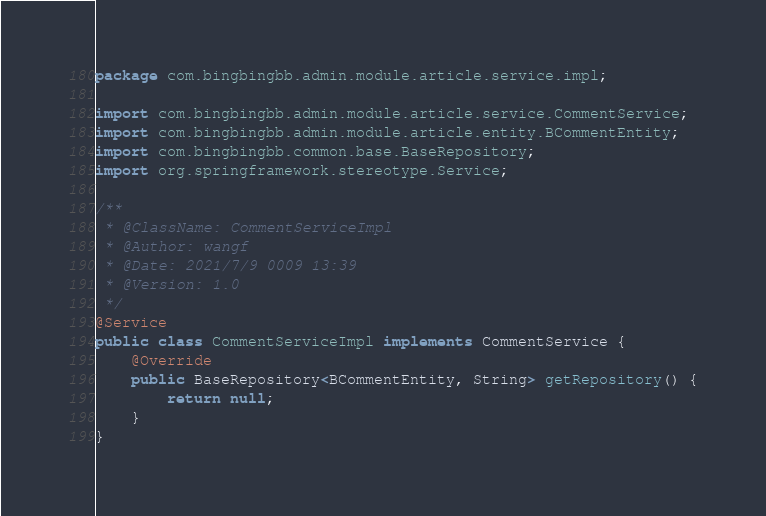Convert code to text. <code><loc_0><loc_0><loc_500><loc_500><_Java_>package com.bingbingbb.admin.module.article.service.impl;

import com.bingbingbb.admin.module.article.service.CommentService;
import com.bingbingbb.admin.module.article.entity.BCommentEntity;
import com.bingbingbb.common.base.BaseRepository;
import org.springframework.stereotype.Service;

/**
 * @ClassName: CommentServiceImpl
 * @Author: wangf
 * @Date: 2021/7/9 0009 13:39
 * @Version: 1.0
 */
@Service
public class CommentServiceImpl implements CommentService {
    @Override
    public BaseRepository<BCommentEntity, String> getRepository() {
        return null;
    }
}
</code> 